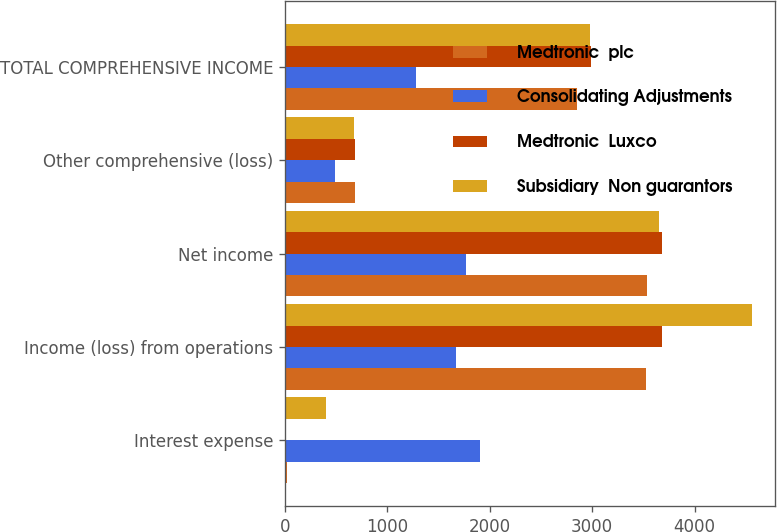Convert chart to OTSL. <chart><loc_0><loc_0><loc_500><loc_500><stacked_bar_chart><ecel><fcel>Interest expense<fcel>Income (loss) from operations<fcel>Net income<fcel>Other comprehensive (loss)<fcel>TOTAL COMPREHENSIVE INCOME<nl><fcel>Medtronic  plc<fcel>25<fcel>3529<fcel>3538<fcel>684<fcel>2854<nl><fcel>Consolidating Adjustments<fcel>1906<fcel>1675<fcel>1771<fcel>493<fcel>1278<nl><fcel>Medtronic  Luxco<fcel>10<fcel>3676<fcel>3676<fcel>684<fcel>2992<nl><fcel>Subsidiary  Non guarantors<fcel>405<fcel>4559<fcel>3656<fcel>673<fcel>2983<nl></chart> 